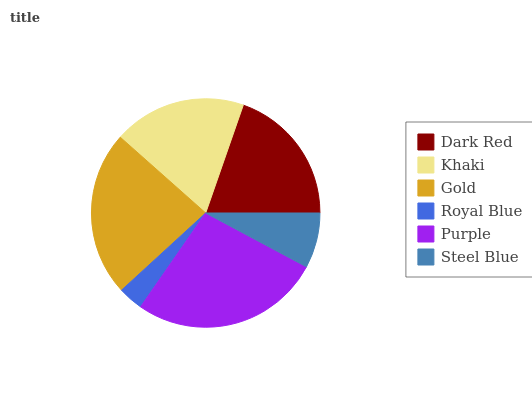Is Royal Blue the minimum?
Answer yes or no. Yes. Is Purple the maximum?
Answer yes or no. Yes. Is Khaki the minimum?
Answer yes or no. No. Is Khaki the maximum?
Answer yes or no. No. Is Dark Red greater than Khaki?
Answer yes or no. Yes. Is Khaki less than Dark Red?
Answer yes or no. Yes. Is Khaki greater than Dark Red?
Answer yes or no. No. Is Dark Red less than Khaki?
Answer yes or no. No. Is Dark Red the high median?
Answer yes or no. Yes. Is Khaki the low median?
Answer yes or no. Yes. Is Khaki the high median?
Answer yes or no. No. Is Purple the low median?
Answer yes or no. No. 